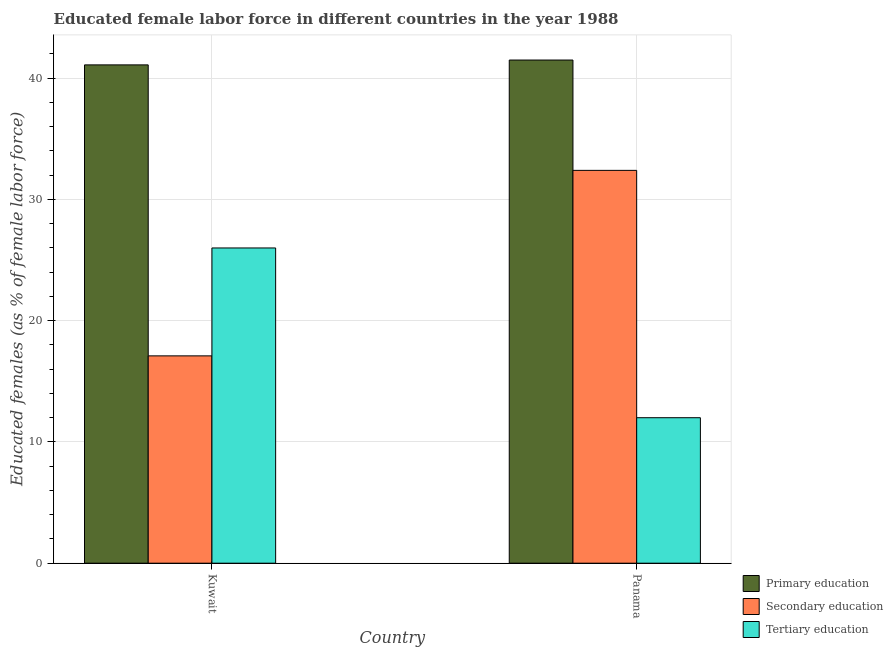How many different coloured bars are there?
Your response must be concise. 3. Are the number of bars on each tick of the X-axis equal?
Keep it short and to the point. Yes. How many bars are there on the 1st tick from the right?
Your answer should be compact. 3. What is the label of the 1st group of bars from the left?
Your answer should be very brief. Kuwait. In how many cases, is the number of bars for a given country not equal to the number of legend labels?
Offer a very short reply. 0. What is the percentage of female labor force who received tertiary education in Panama?
Give a very brief answer. 12. Across all countries, what is the maximum percentage of female labor force who received secondary education?
Keep it short and to the point. 32.4. Across all countries, what is the minimum percentage of female labor force who received primary education?
Make the answer very short. 41.1. In which country was the percentage of female labor force who received secondary education maximum?
Make the answer very short. Panama. In which country was the percentage of female labor force who received primary education minimum?
Provide a succinct answer. Kuwait. What is the total percentage of female labor force who received secondary education in the graph?
Provide a succinct answer. 49.5. What is the difference between the percentage of female labor force who received tertiary education in Kuwait and that in Panama?
Keep it short and to the point. 14. What is the difference between the percentage of female labor force who received primary education in Kuwait and the percentage of female labor force who received secondary education in Panama?
Provide a short and direct response. 8.7. What is the difference between the percentage of female labor force who received secondary education and percentage of female labor force who received primary education in Panama?
Keep it short and to the point. -9.1. In how many countries, is the percentage of female labor force who received secondary education greater than 34 %?
Offer a very short reply. 0. What is the ratio of the percentage of female labor force who received secondary education in Kuwait to that in Panama?
Keep it short and to the point. 0.53. Is the percentage of female labor force who received primary education in Kuwait less than that in Panama?
Offer a terse response. Yes. What does the 1st bar from the left in Kuwait represents?
Provide a succinct answer. Primary education. What does the 2nd bar from the right in Panama represents?
Keep it short and to the point. Secondary education. Is it the case that in every country, the sum of the percentage of female labor force who received primary education and percentage of female labor force who received secondary education is greater than the percentage of female labor force who received tertiary education?
Keep it short and to the point. Yes. How many bars are there?
Your answer should be very brief. 6. Are all the bars in the graph horizontal?
Offer a very short reply. No. How many countries are there in the graph?
Provide a short and direct response. 2. Are the values on the major ticks of Y-axis written in scientific E-notation?
Provide a short and direct response. No. Does the graph contain grids?
Keep it short and to the point. Yes. Where does the legend appear in the graph?
Your response must be concise. Bottom right. How many legend labels are there?
Provide a short and direct response. 3. How are the legend labels stacked?
Your answer should be compact. Vertical. What is the title of the graph?
Make the answer very short. Educated female labor force in different countries in the year 1988. What is the label or title of the X-axis?
Offer a very short reply. Country. What is the label or title of the Y-axis?
Provide a succinct answer. Educated females (as % of female labor force). What is the Educated females (as % of female labor force) in Primary education in Kuwait?
Provide a short and direct response. 41.1. What is the Educated females (as % of female labor force) in Secondary education in Kuwait?
Provide a short and direct response. 17.1. What is the Educated females (as % of female labor force) of Primary education in Panama?
Keep it short and to the point. 41.5. What is the Educated females (as % of female labor force) in Secondary education in Panama?
Your answer should be very brief. 32.4. Across all countries, what is the maximum Educated females (as % of female labor force) of Primary education?
Provide a succinct answer. 41.5. Across all countries, what is the maximum Educated females (as % of female labor force) in Secondary education?
Give a very brief answer. 32.4. Across all countries, what is the minimum Educated females (as % of female labor force) of Primary education?
Offer a very short reply. 41.1. Across all countries, what is the minimum Educated females (as % of female labor force) of Secondary education?
Provide a short and direct response. 17.1. What is the total Educated females (as % of female labor force) of Primary education in the graph?
Your response must be concise. 82.6. What is the total Educated females (as % of female labor force) in Secondary education in the graph?
Give a very brief answer. 49.5. What is the difference between the Educated females (as % of female labor force) in Primary education in Kuwait and that in Panama?
Give a very brief answer. -0.4. What is the difference between the Educated females (as % of female labor force) in Secondary education in Kuwait and that in Panama?
Your response must be concise. -15.3. What is the difference between the Educated females (as % of female labor force) in Primary education in Kuwait and the Educated females (as % of female labor force) in Tertiary education in Panama?
Your answer should be compact. 29.1. What is the average Educated females (as % of female labor force) of Primary education per country?
Keep it short and to the point. 41.3. What is the average Educated females (as % of female labor force) in Secondary education per country?
Your response must be concise. 24.75. What is the average Educated females (as % of female labor force) in Tertiary education per country?
Give a very brief answer. 19. What is the difference between the Educated females (as % of female labor force) of Secondary education and Educated females (as % of female labor force) of Tertiary education in Kuwait?
Your response must be concise. -8.9. What is the difference between the Educated females (as % of female labor force) in Primary education and Educated females (as % of female labor force) in Tertiary education in Panama?
Offer a terse response. 29.5. What is the difference between the Educated females (as % of female labor force) of Secondary education and Educated females (as % of female labor force) of Tertiary education in Panama?
Offer a very short reply. 20.4. What is the ratio of the Educated females (as % of female labor force) in Secondary education in Kuwait to that in Panama?
Provide a succinct answer. 0.53. What is the ratio of the Educated females (as % of female labor force) of Tertiary education in Kuwait to that in Panama?
Offer a terse response. 2.17. What is the difference between the highest and the second highest Educated females (as % of female labor force) in Primary education?
Offer a very short reply. 0.4. What is the difference between the highest and the second highest Educated females (as % of female labor force) in Secondary education?
Ensure brevity in your answer.  15.3. What is the difference between the highest and the lowest Educated females (as % of female labor force) in Primary education?
Give a very brief answer. 0.4. 